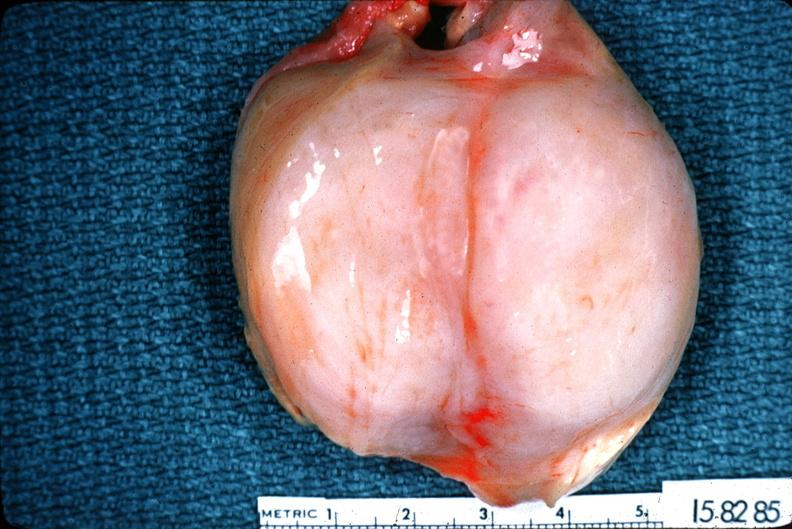does this image show schwannoma?
Answer the question using a single word or phrase. Yes 